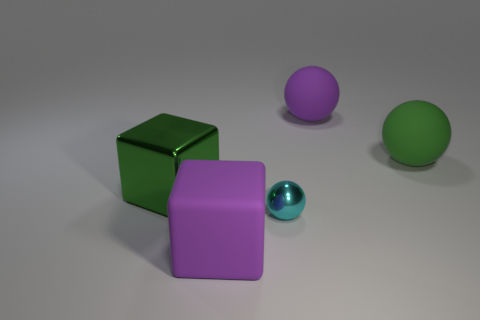Add 2 balls. How many objects exist? 7 Subtract all cubes. How many objects are left? 3 Subtract 0 yellow spheres. How many objects are left? 5 Subtract all cyan spheres. Subtract all large rubber balls. How many objects are left? 2 Add 2 purple matte things. How many purple matte things are left? 4 Add 5 green rubber things. How many green rubber things exist? 6 